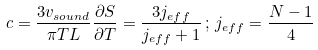<formula> <loc_0><loc_0><loc_500><loc_500>c = \frac { 3 v _ { s o u n d } } { \pi T L } \frac { \partial S } { \partial T } = \frac { 3 j _ { e f f } } { j _ { e f f } + 1 } \, ; \, j _ { e f f } = \frac { N - 1 } { 4 }</formula> 